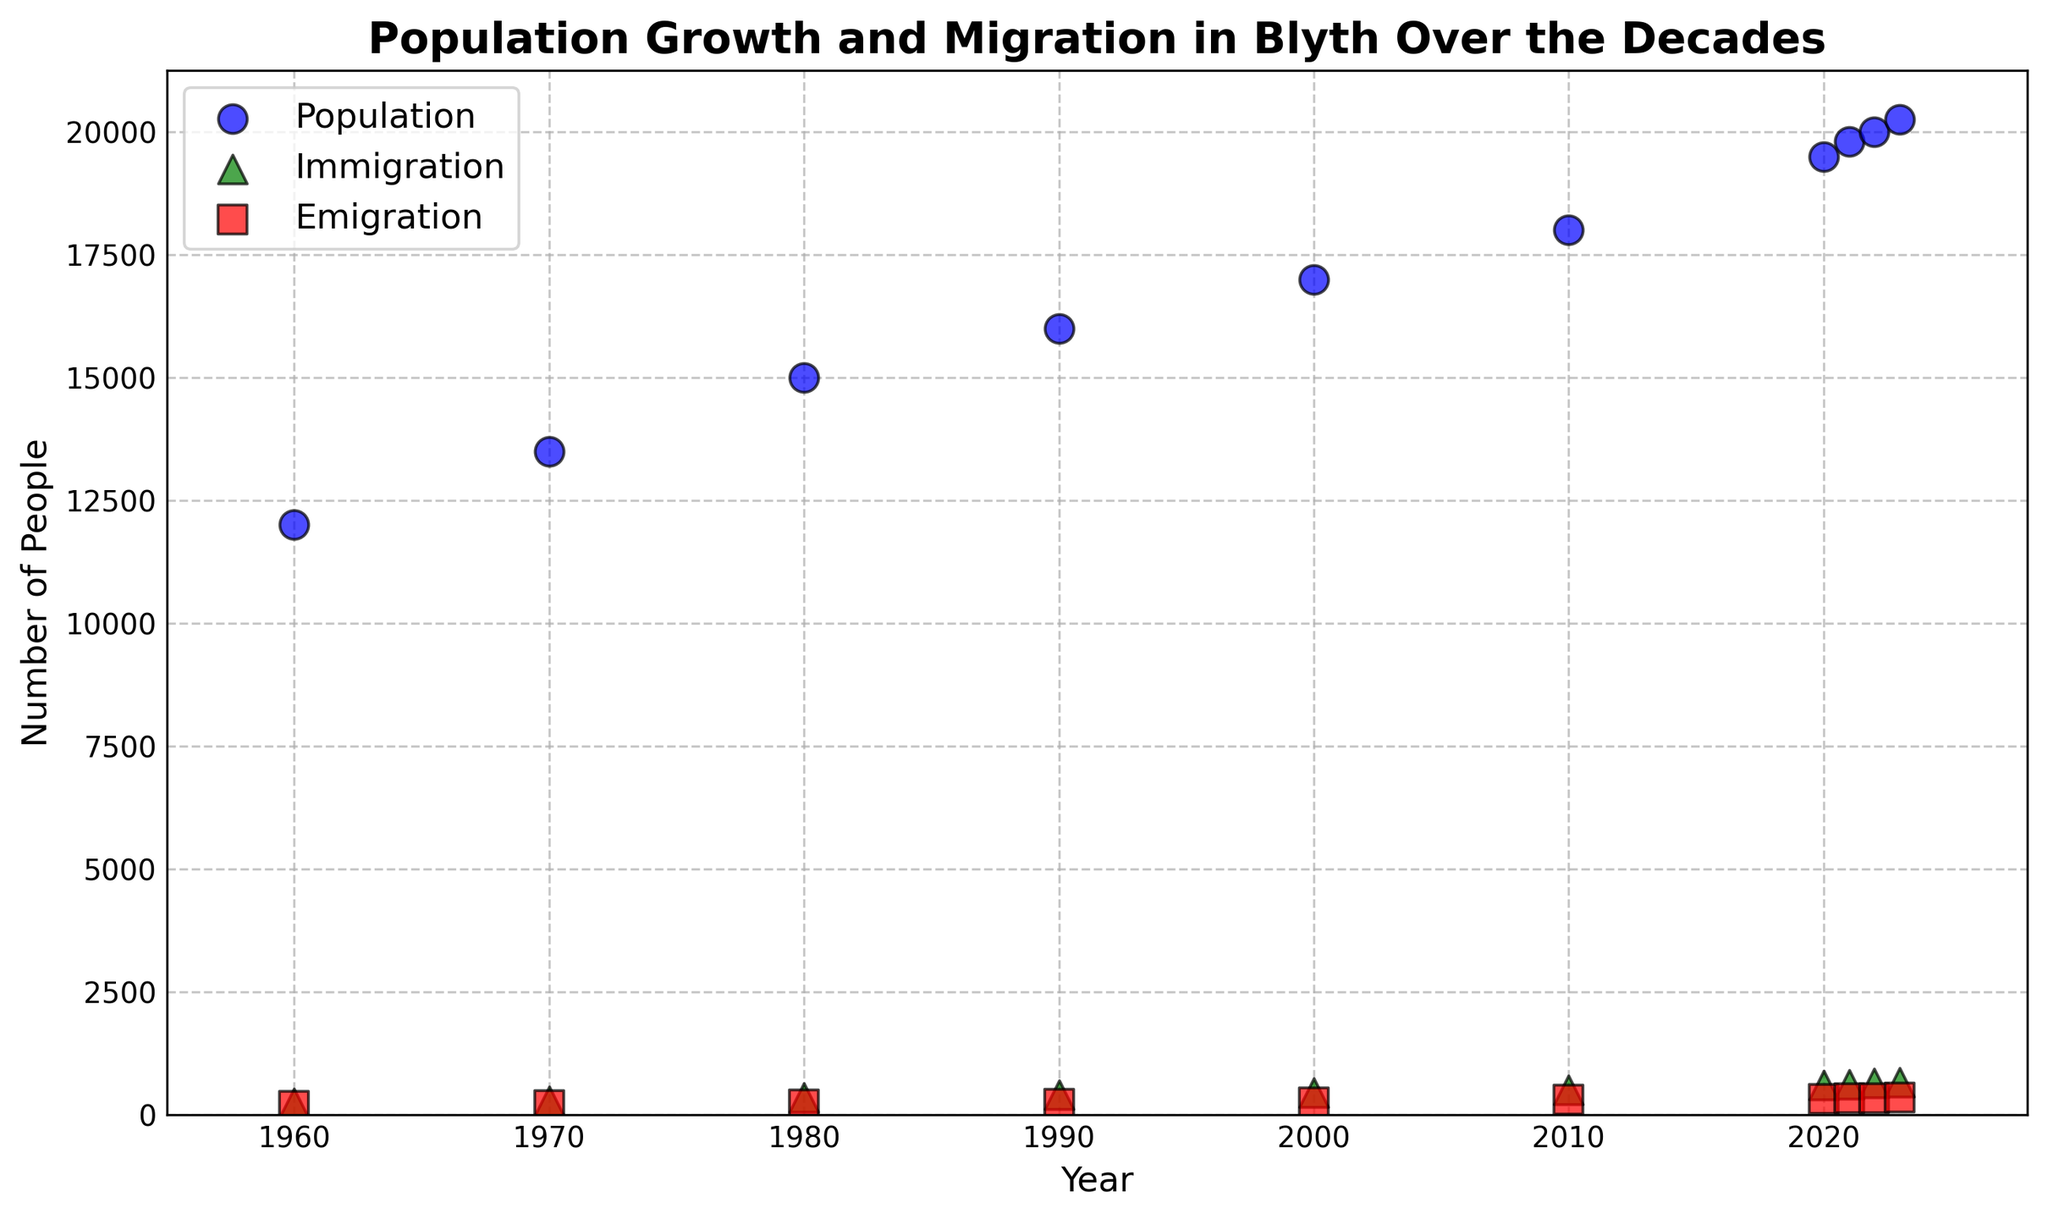What is the population of Blyth in 1980? Look at the blue scatter points and find the one corresponding to the year 1980. The y-value of this point represents the population.
Answer: 15000 Which year saw the highest immigration? Look at the green scatter points representing immigration. Identify the point with the highest y-value and note the corresponding year on the x-axis.
Answer: 2023 Did population growth increase steadily over the decades from 1960 to 2023? Analyze the blue scatter points on the plot from left (1960) to right (2023). Check if each subsequent point is higher than the previous one.
Answer: Yes Compare immigration and emigration in 2010. Which was higher? Find the green and red scatter points corresponding to the year 2010. Compare their y-values and see which is higher.
Answer: Immigration How much did the population grow from 1960 to 2023? Subtract the population value at 1960 (12000) from the population value at 2023 (20250).
Answer: 8250 By how much did immigration increase from 2000 to 2023? Subtract the immigration value at 2000 (450) from the immigration value at 2023 (660).
Answer: 210 What is the trend in emigration from 1960 to 2023? Look at the red scatter points corresponding to the emigration values over the years. Check if the values increase, decrease, or remain constant as the years progress.
Answer: Increase What is the difference between immigration and emigration in 2022? Subtract the emigration value at 2022 (340) from the immigration value at 2022 (640).
Answer: 300 In which year did Blyth see the smallest difference between immigration and emigration? Calculate the difference between immigration and emigration for each year, then identify the year with the smallest calculated difference.
Answer: 1960 What visual marker represents emigration on the plot? Observe the scatter points on the plot and identify the shape used for emigration data.
Answer: Square 